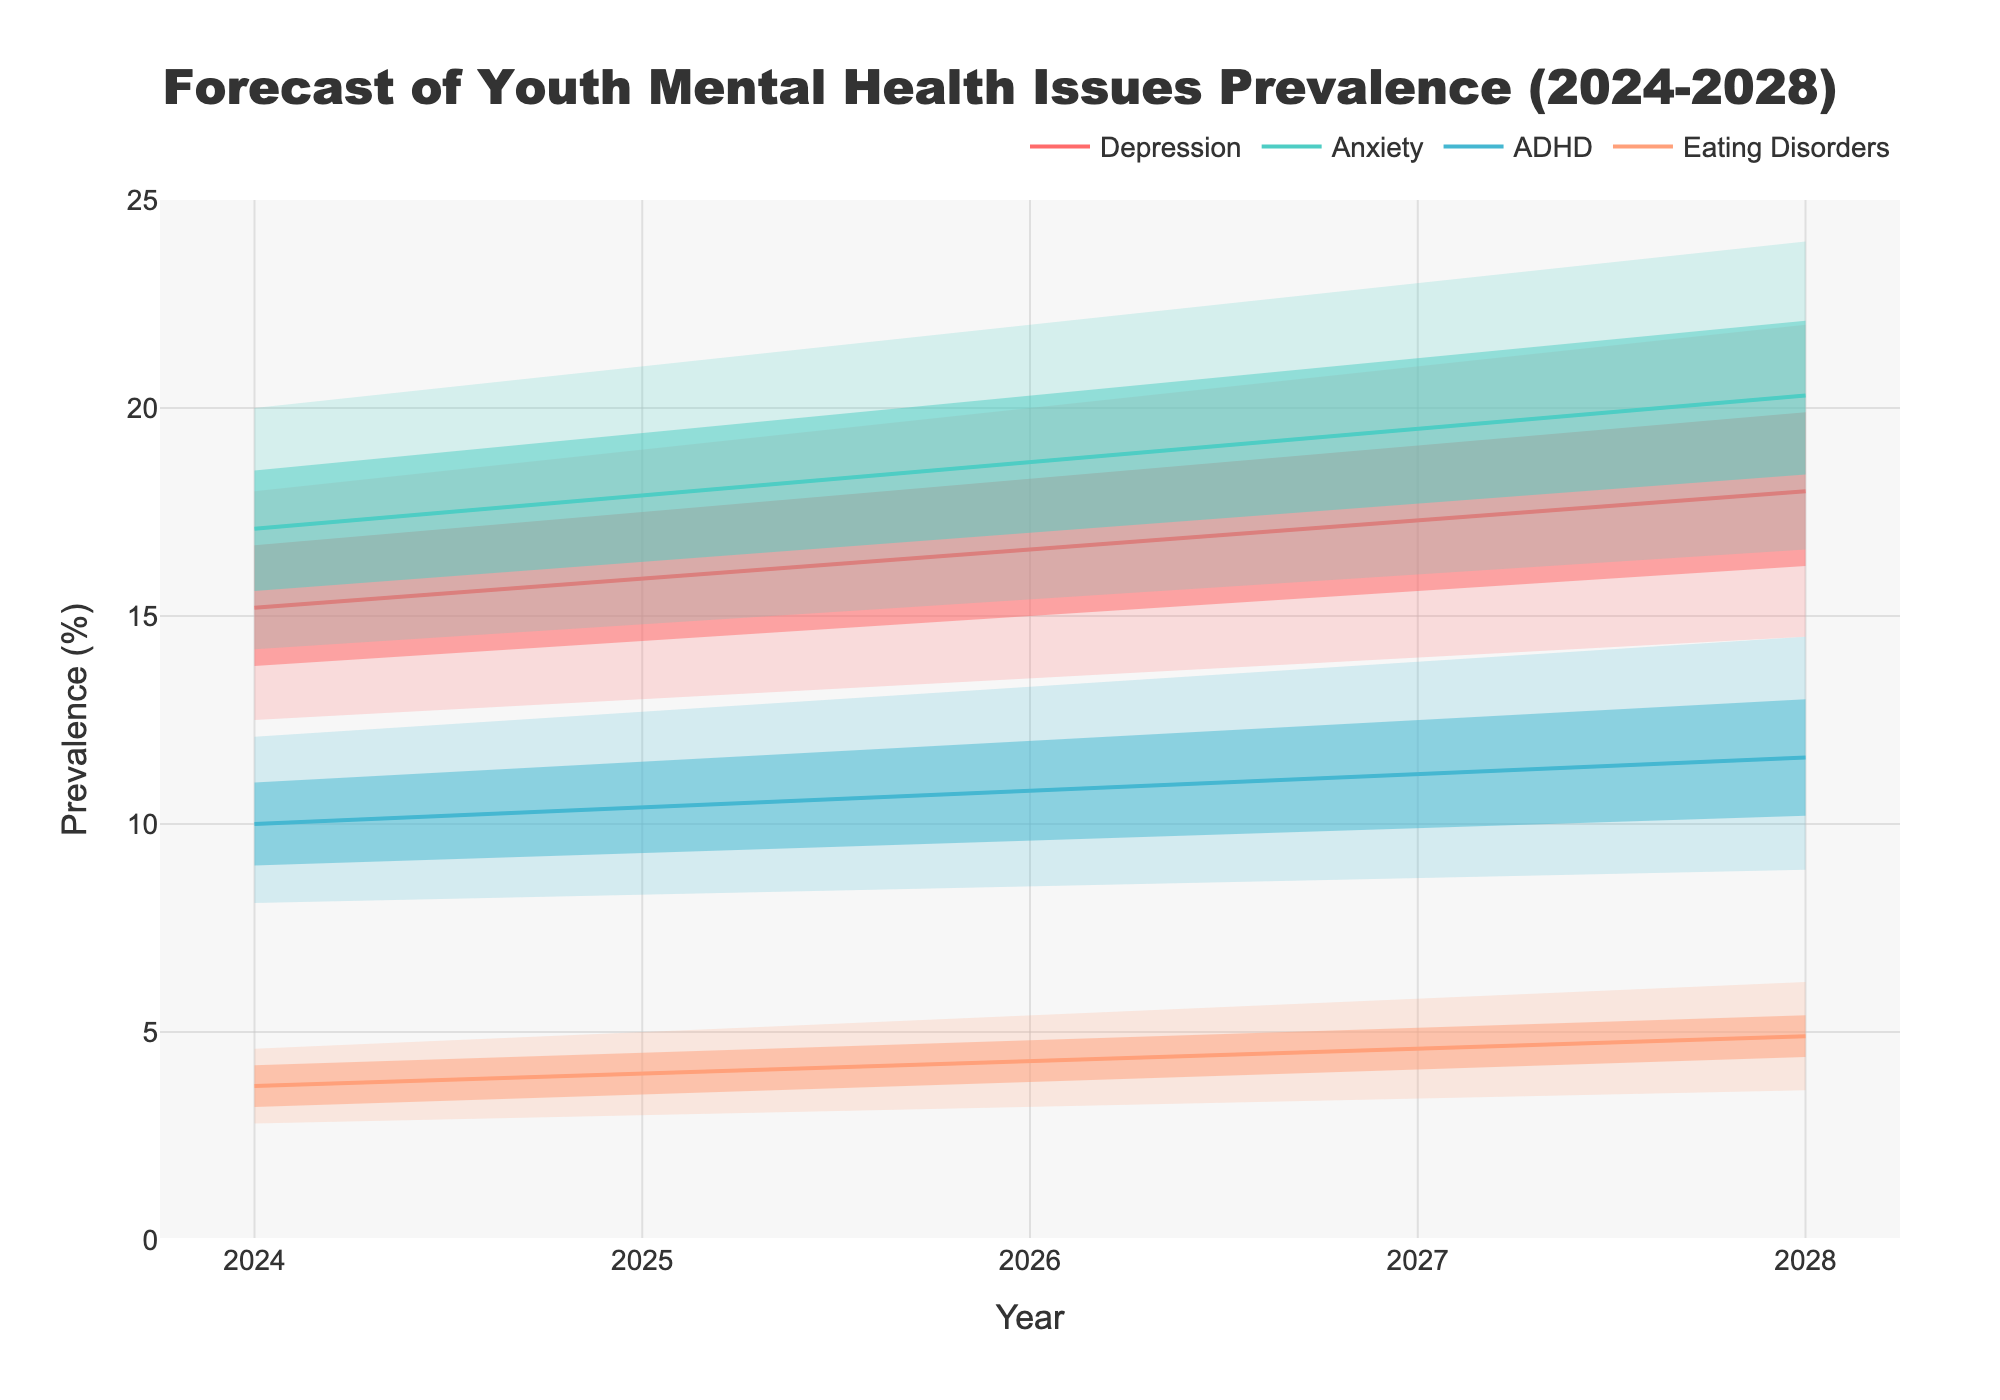What's the title of the chart? The title of the chart is usually stated at the top of the figure and summarizes the content. In this case, the title "Forecast of Youth Mental Health Issues Prevalence (2024-2028)" succinctly describes what the chart is about.
Answer: Forecast of Youth Mental Health Issues Prevalence (2024-2028) What is the central estimate of anxiety prevalence in 2026? To find this, locate the year 2026 on the x-axis, then find the corresponding dot or line on the chart for anxiety. The central estimate is the main line, which for 2026 is marked at 18.7%.
Answer: 18.7% Which disorder shows the highest central estimate in 2028? Compare the central estimates (main lines) for all disorders in 2028. The highest one for 2028 is Anxiety at 20.3%.
Answer: Anxiety How does the prevalence of eating disorders in 2024 compare to that in 2028 (central estimate)? Locate the central estimate for eating disorders in 2024 (3.7%) and compare it to the central estimate for 2028 (4.9%). Calculate the difference: 4.9% - 3.7% = 1.2%.
Answer: The prevalence increased by 1.2% What are the lower and upper bounds of ADHD prevalence in 2025? Locate the year 2025 for ADHD and identify the lower bound (8.3%) and upper bound (12.7%) indicated by the shaded region.
Answer: 8.3% and 12.7% During which year does the central estimate for depression cross 18%? Follow the line for depression and identify the point where it exceeds 18%. In 2027, the central estimate of depression is 18.0%.
Answer: 2028 In 2027, which disorder has the smallest range between its lower and upper bounds? For 2027, calculate the range for each disorder by subtracting the lower bound from the upper bound: Depression (21.0% - 14.0% = 7%), Anxiety (23.0% - 16.0% = 7%), ADHD (13.9% - 8.7% = 5.2%), Eating Disorders (5.8% - 3.4% = 2.4%). The smallest range is for Eating Disorders.
Answer: Eating Disorders How does the range of estimates (lower bound to upper bound) for depression change from 2024 to 2028? Calculate the range for depression in 2024 (18.0% - 12.5% = 5.5%) and in 2028 (22.0% - 14.5% = 7.5%). The range increases by (7.5% - 5.5%) = 2%.
Answer: The range increased by 2% Which disorder shows the steadiest increase in prevalence central estimates from 2024 to 2028? Examine the central estimate lines for all disorders and note the year-to-year increases. ADHD shows a steadier slope with a consistent, gradual increase from 10.0% in 2024 to 11.6% in 2028 (an average increase of about 0.4% per year).
Answer: ADHD 